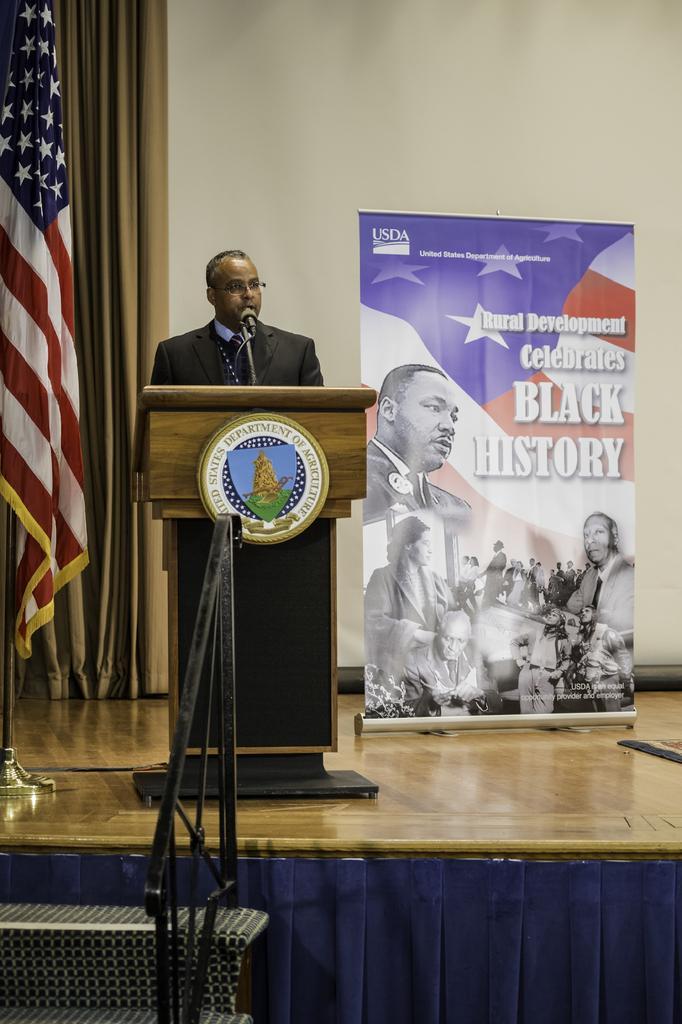Please provide a concise description of this image. In this image we can see a man standing behind a podium containing a microphone on a stand and a board with some text on it. On the left side of the image we can see a flag on pole, curtains, staircase and railing. In the background, we can see a banner with some pictures and text. 